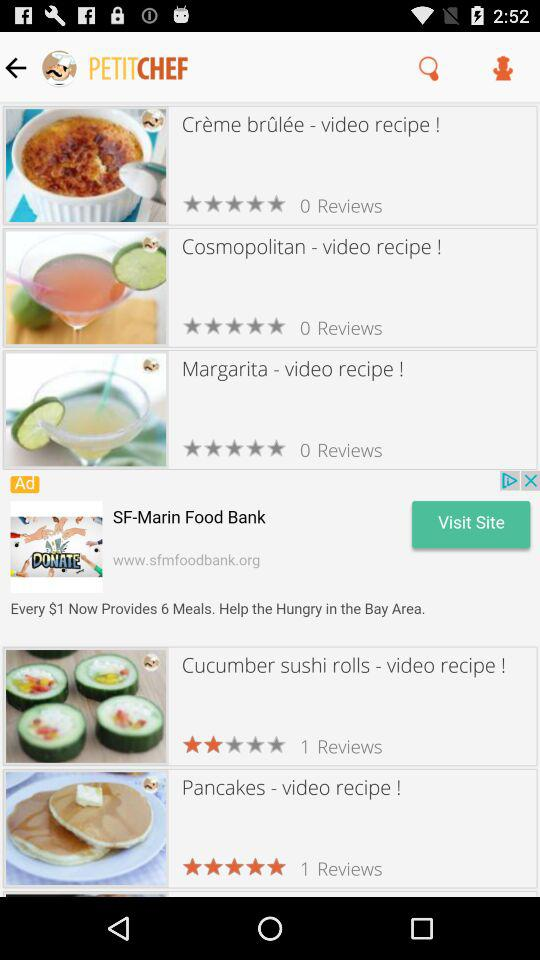What is the name of the recipe with a 5 star rating? The name of the recipe is "Pancakes - video recipe!". 